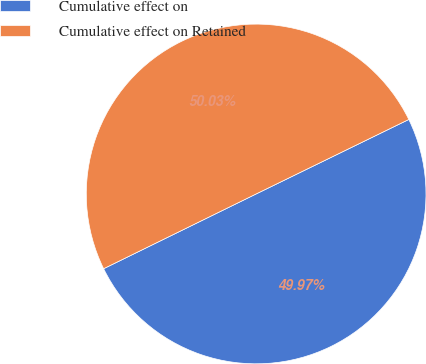Convert chart to OTSL. <chart><loc_0><loc_0><loc_500><loc_500><pie_chart><fcel>Cumulative effect on<fcel>Cumulative effect on Retained<nl><fcel>49.97%<fcel>50.03%<nl></chart> 